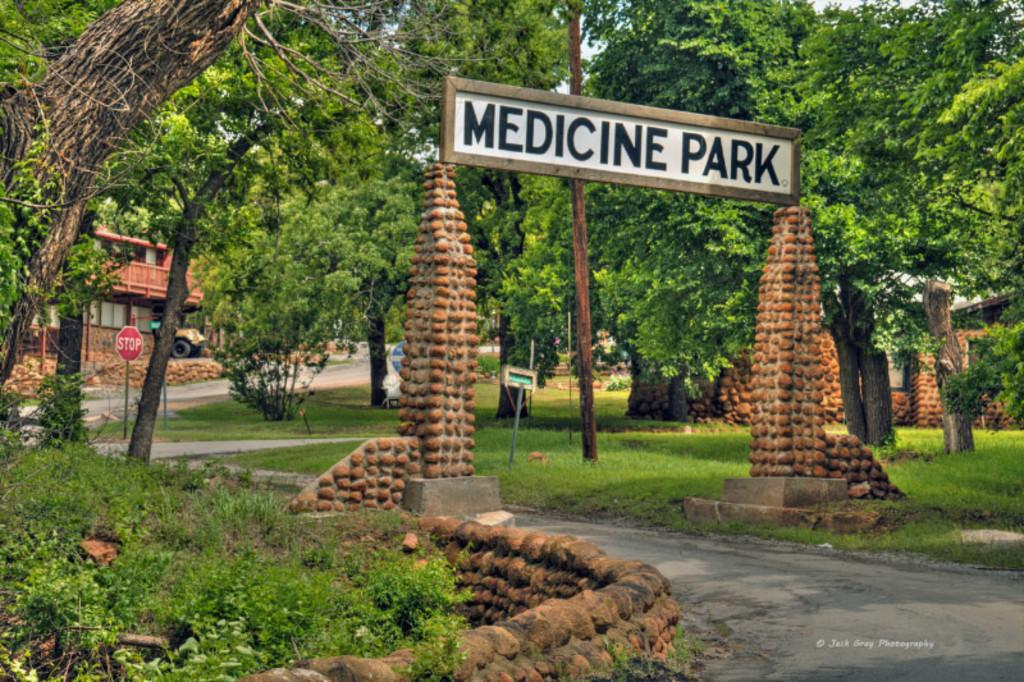What is the main subject of the image? The main subject of the image is the entrance gate of a park. What type of vegetation can be seen in the image? There are trees in the image. What is the purpose of the sign board in the image? The purpose of the sign board in the image is to provide information or directions. What type of structure is visible in the image? There is a building in the image. What is on the left side of the image? There is grass on the left side of the image. What is in the middle of the image? There is a road in the middle of the image. What type of dress is the tree wearing in the image? Trees do not wear dresses; they are plants. The question is not relevant to the image. 